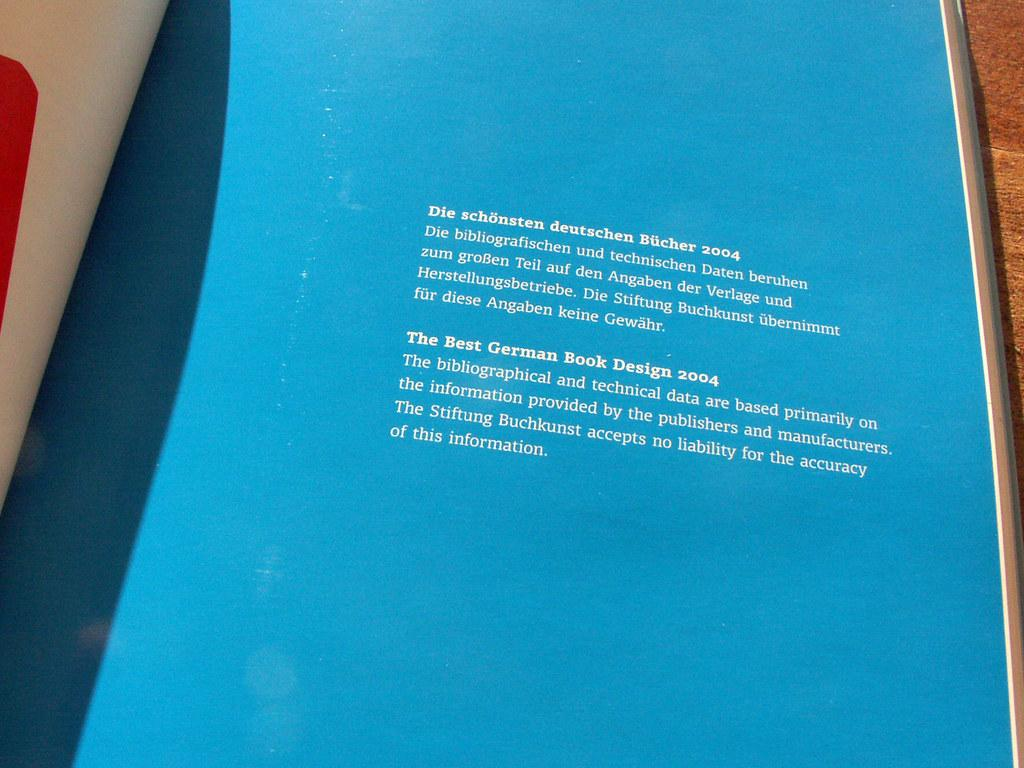<image>
Create a compact narrative representing the image presented. A page with text in both English and German with the English headline reading The Best German Book Design 2004 